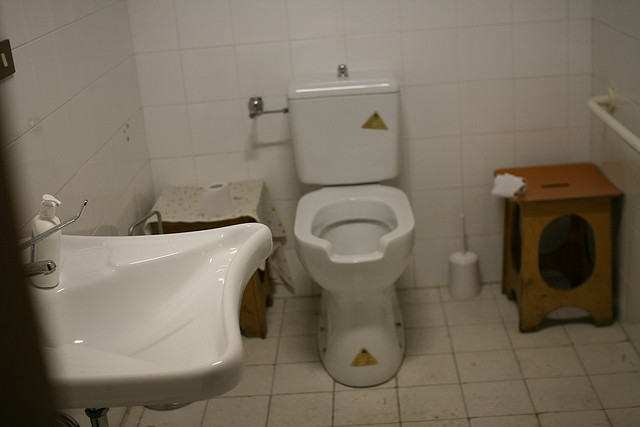How many sinks are in this room? There is one sink in the room, with a sleek design, located on the left as you view the image. It sits adjacent to a toilet, and the two fixtures together provide the essential functions for this presumably small bathroom space. 